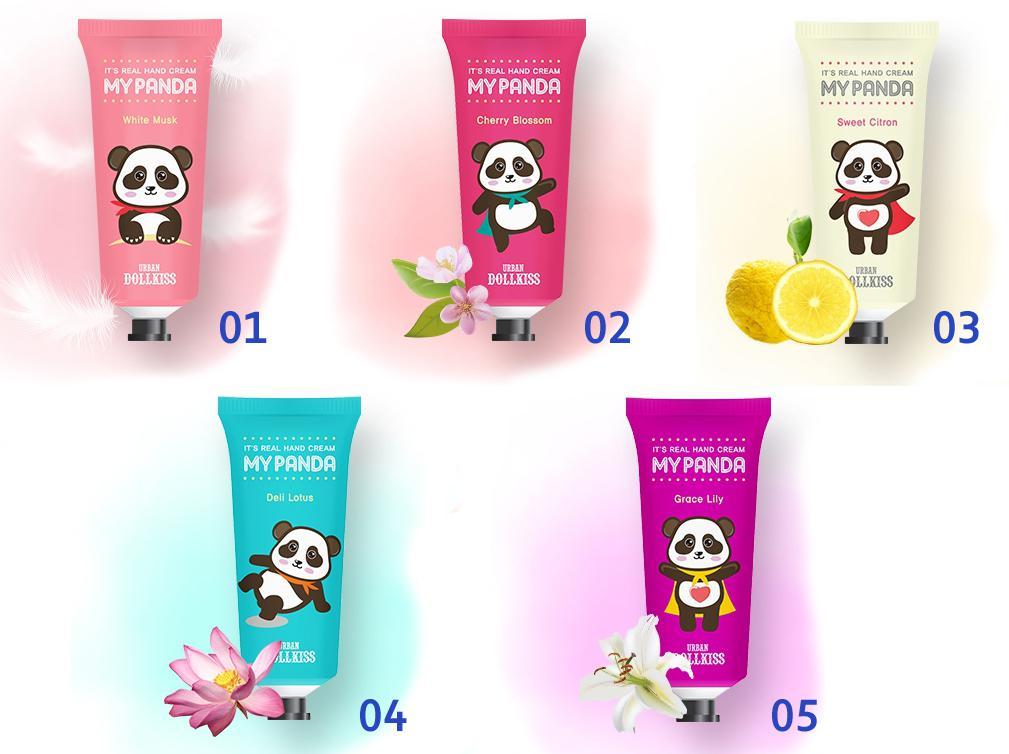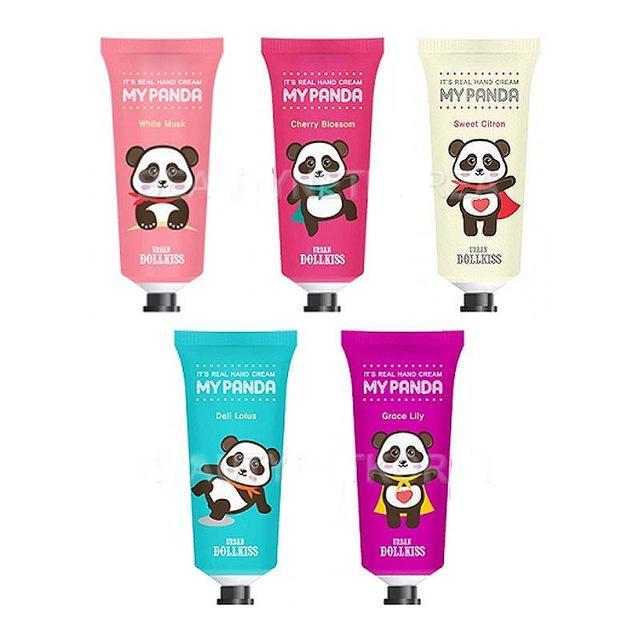The first image is the image on the left, the second image is the image on the right. Assess this claim about the two images: "Each image shows five tubes, each a different color and with assorted cartoon pandas on their fronts.". Correct or not? Answer yes or no. Yes. The first image is the image on the left, the second image is the image on the right. Examine the images to the left and right. Is the description "There are pink, red, and white bottles next to each other in that order, and also blue and purple in that order." accurate? Answer yes or no. Yes. 